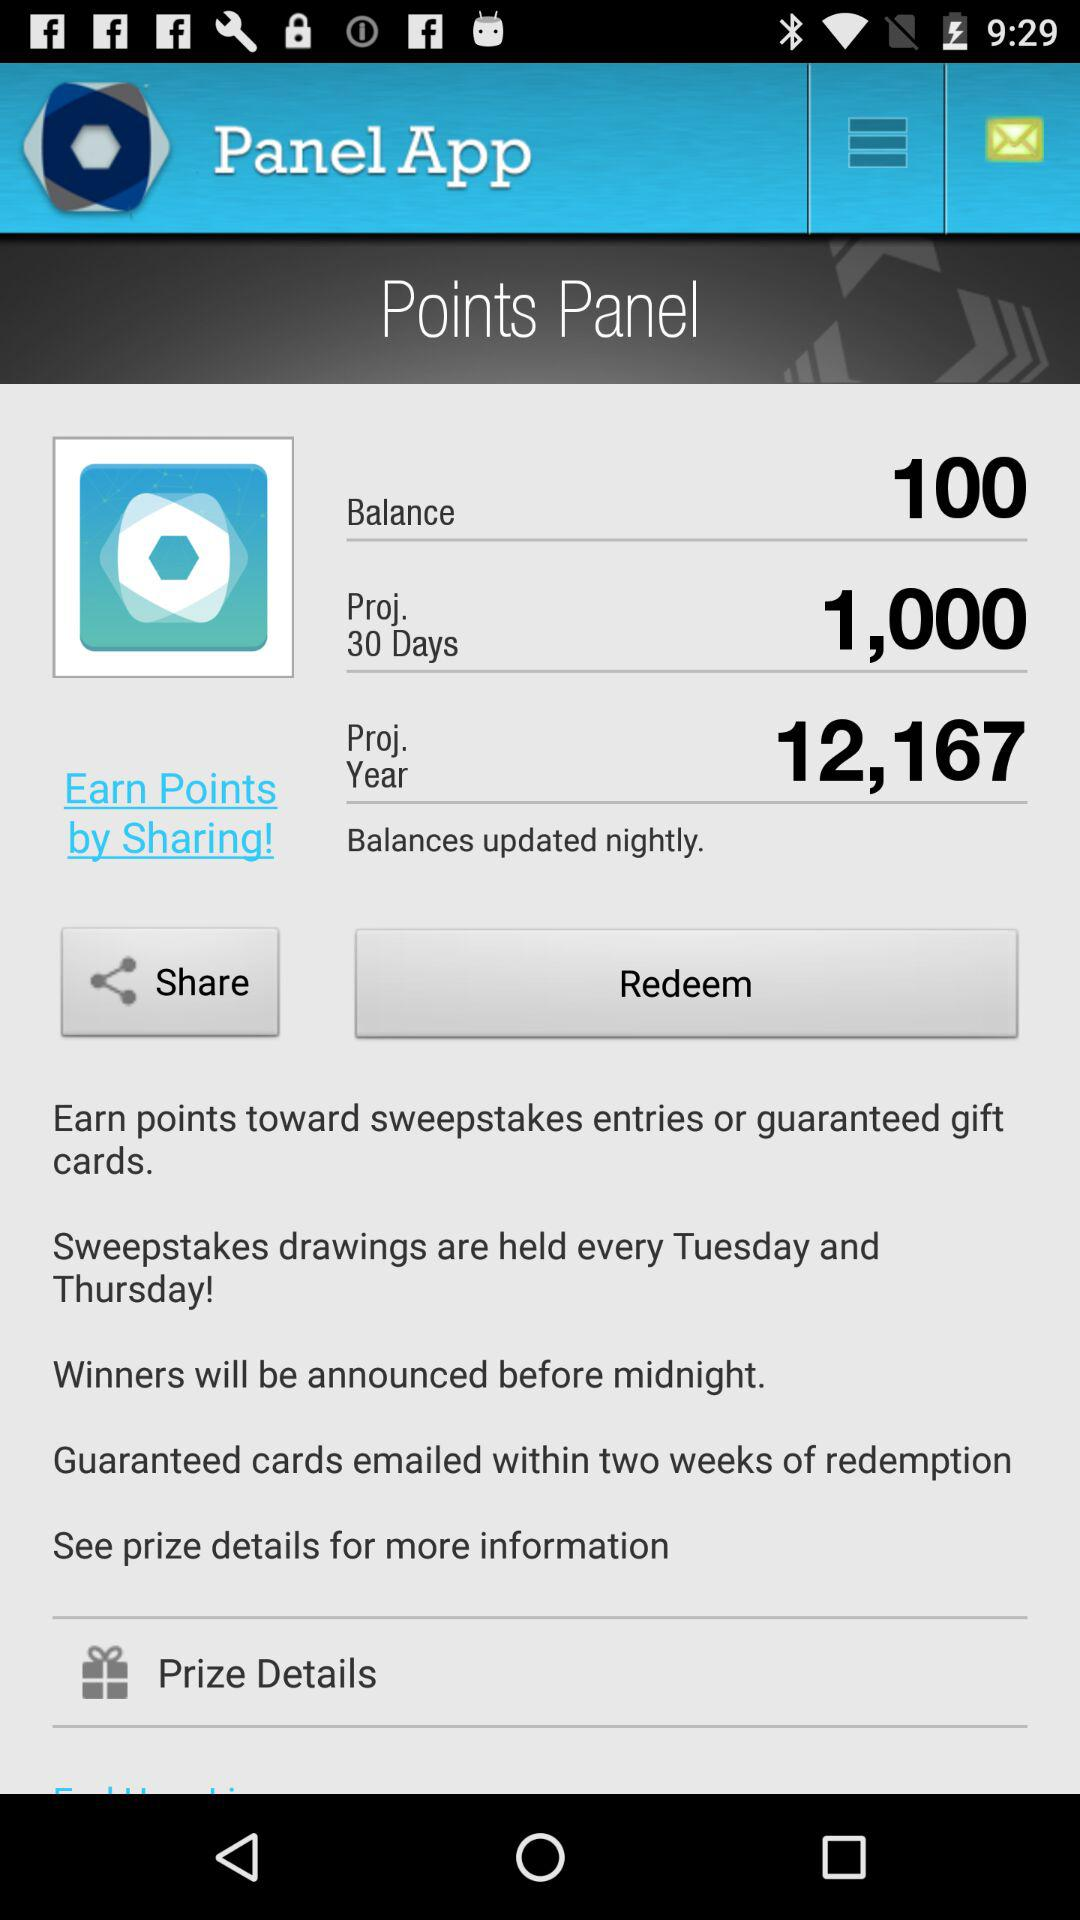How many points are there for Proj. for 30 days? There are 1,000 points. 